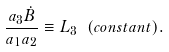<formula> <loc_0><loc_0><loc_500><loc_500>\frac { a _ { 3 } \dot { B } } { a _ { 1 } a _ { 2 } } \equiv L _ { 3 } \ ( c o n s t a n t ) .</formula> 